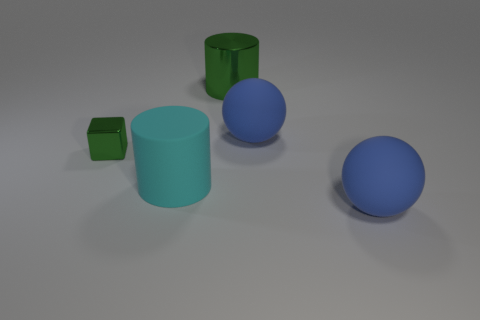Is the material of the big cyan cylinder the same as the green cylinder?
Offer a terse response. No. What number of other objects are the same size as the cyan matte cylinder?
Give a very brief answer. 3. The big matte object behind the big cylinder that is in front of the tiny shiny object is what color?
Ensure brevity in your answer.  Blue. How many other objects are there of the same shape as the large cyan thing?
Keep it short and to the point. 1. Is there a blue thing made of the same material as the large green cylinder?
Provide a short and direct response. No. There is a green object that is the same size as the cyan object; what material is it?
Your answer should be compact. Metal. What color is the big sphere to the right of the blue matte object that is to the left of the large blue rubber object in front of the cyan cylinder?
Offer a terse response. Blue. There is a large blue object behind the green block; does it have the same shape as the green object on the right side of the tiny green metal cube?
Keep it short and to the point. No. What number of large red metallic cylinders are there?
Make the answer very short. 0. What is the color of the other cylinder that is the same size as the metal cylinder?
Make the answer very short. Cyan. 